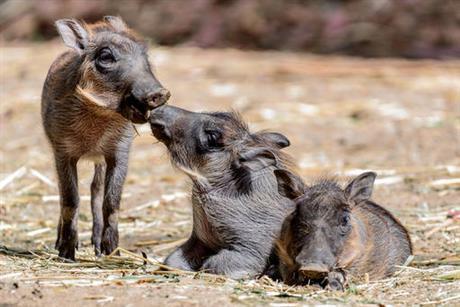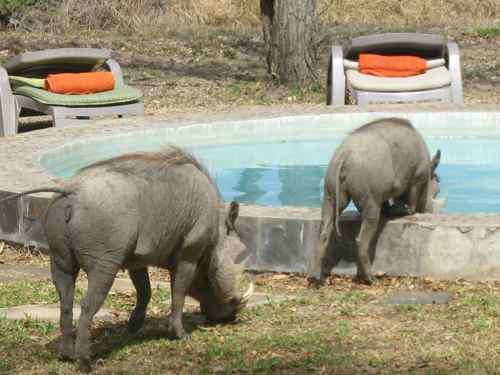The first image is the image on the left, the second image is the image on the right. Assess this claim about the two images: "The image on the left contains no more than two wart hogs.". Correct or not? Answer yes or no. No. The first image is the image on the left, the second image is the image on the right. Analyze the images presented: Is the assertion "At least one warthog is near water." valid? Answer yes or no. Yes. 